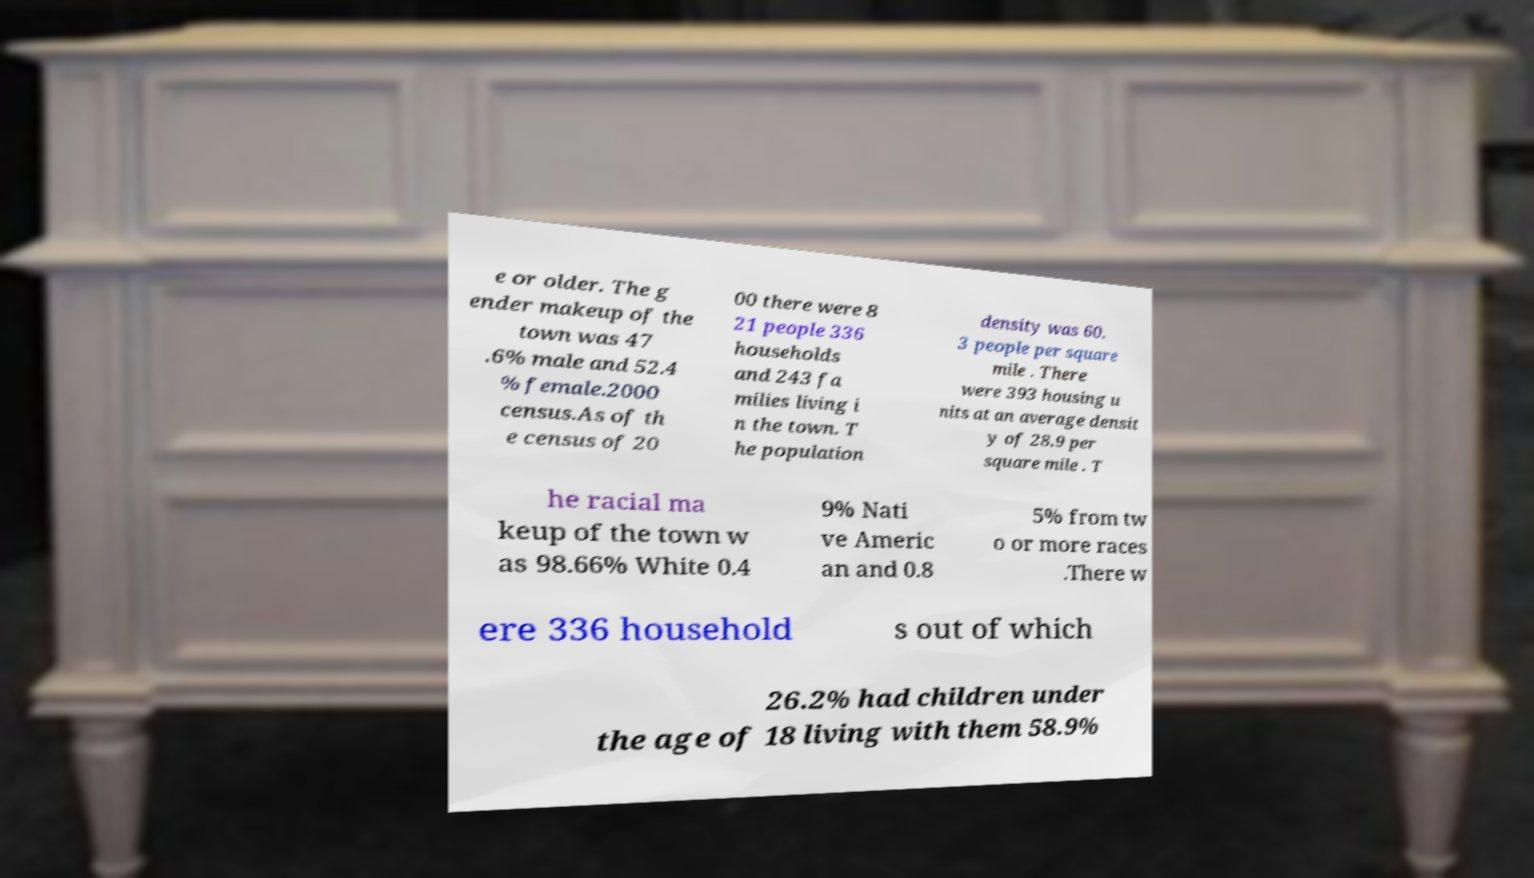Could you extract and type out the text from this image? e or older. The g ender makeup of the town was 47 .6% male and 52.4 % female.2000 census.As of th e census of 20 00 there were 8 21 people 336 households and 243 fa milies living i n the town. T he population density was 60. 3 people per square mile . There were 393 housing u nits at an average densit y of 28.9 per square mile . T he racial ma keup of the town w as 98.66% White 0.4 9% Nati ve Americ an and 0.8 5% from tw o or more races .There w ere 336 household s out of which 26.2% had children under the age of 18 living with them 58.9% 